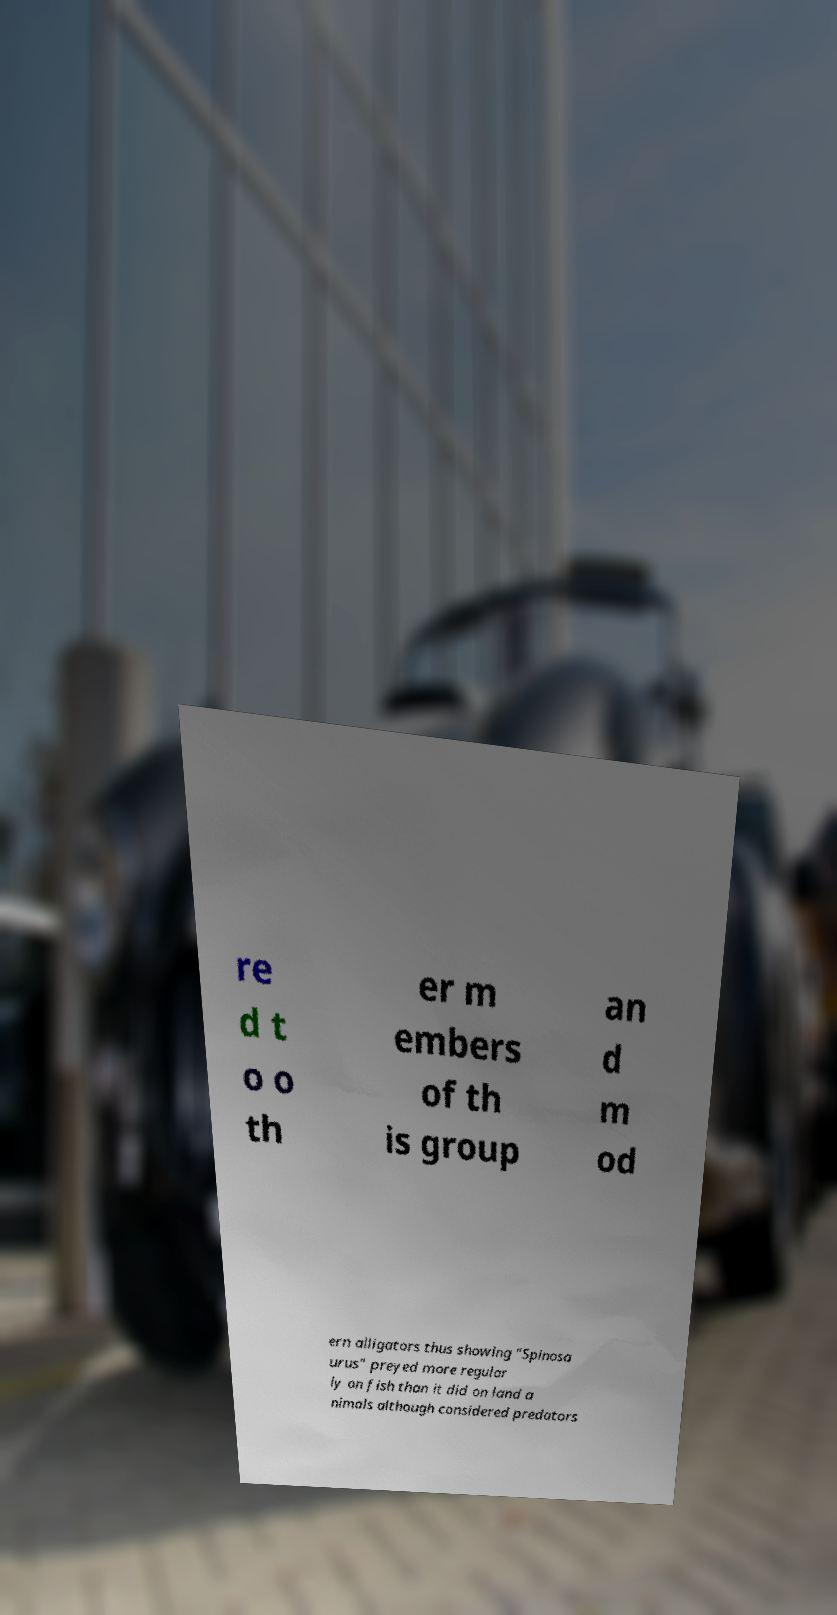What messages or text are displayed in this image? I need them in a readable, typed format. re d t o o th er m embers of th is group an d m od ern alligators thus showing "Spinosa urus" preyed more regular ly on fish than it did on land a nimals although considered predators 